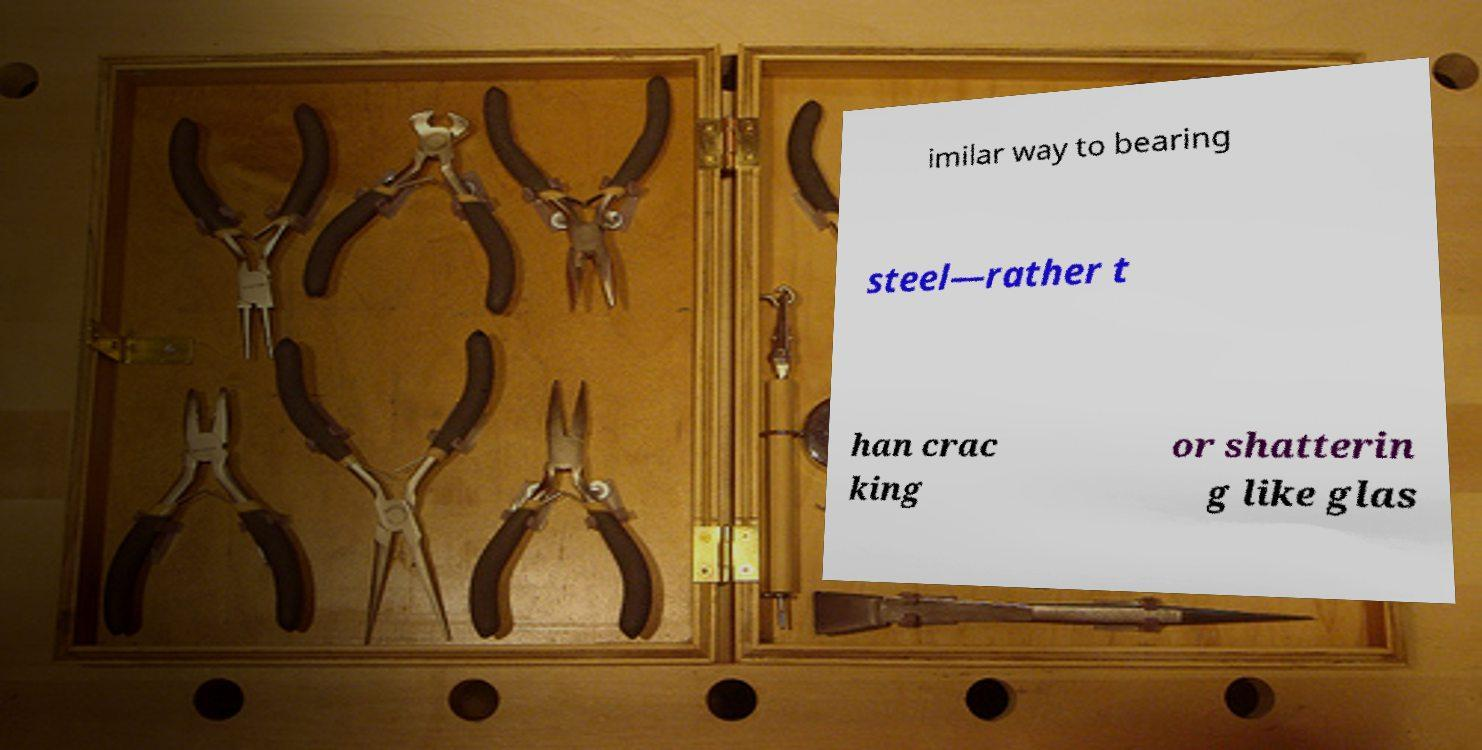Could you assist in decoding the text presented in this image and type it out clearly? imilar way to bearing steel—rather t han crac king or shatterin g like glas 